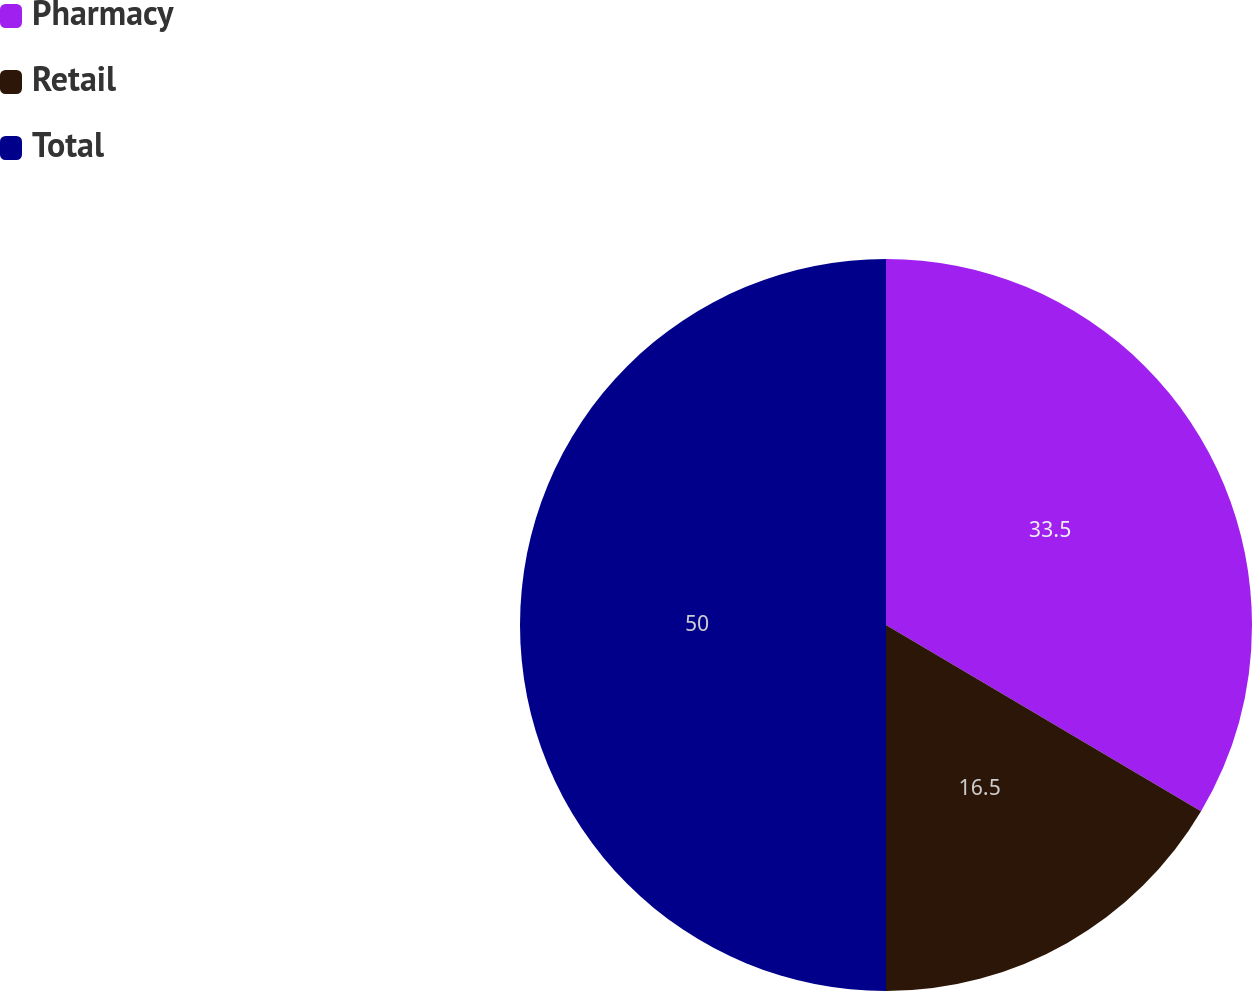Convert chart to OTSL. <chart><loc_0><loc_0><loc_500><loc_500><pie_chart><fcel>Pharmacy<fcel>Retail<fcel>Total<nl><fcel>33.5%<fcel>16.5%<fcel>50.0%<nl></chart> 